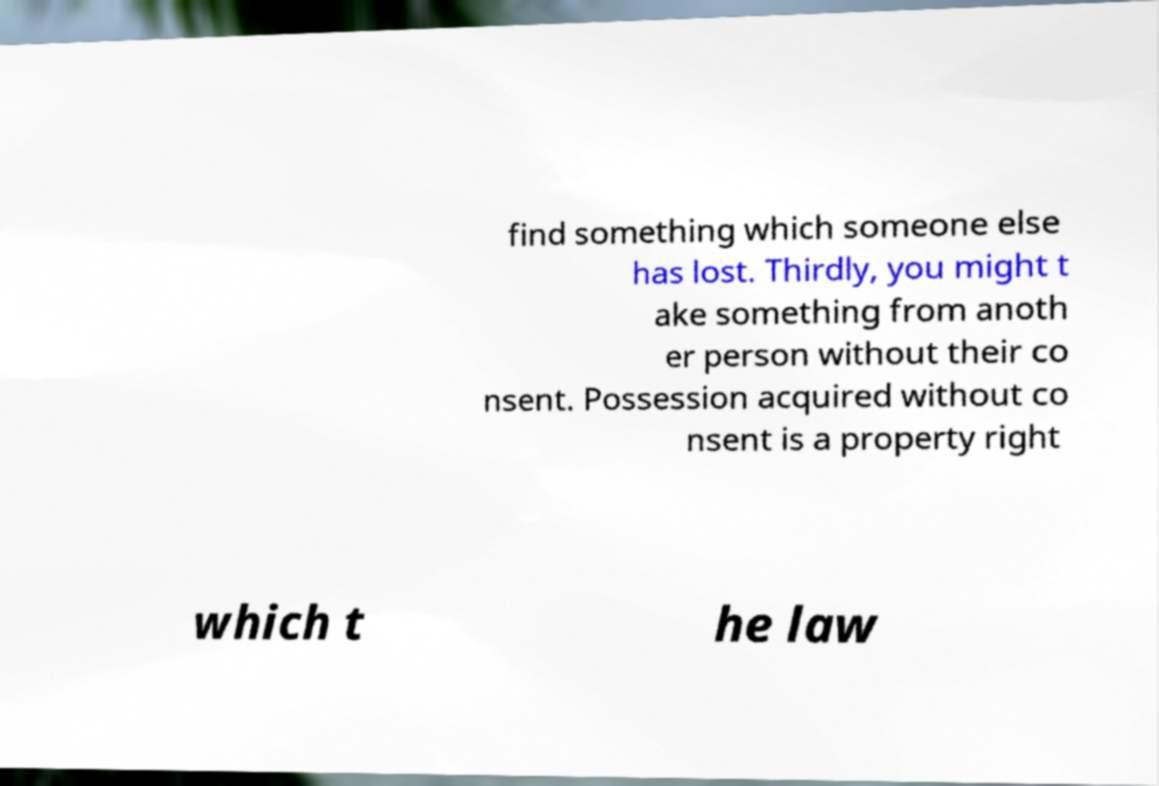Could you assist in decoding the text presented in this image and type it out clearly? find something which someone else has lost. Thirdly, you might t ake something from anoth er person without their co nsent. Possession acquired without co nsent is a property right which t he law 